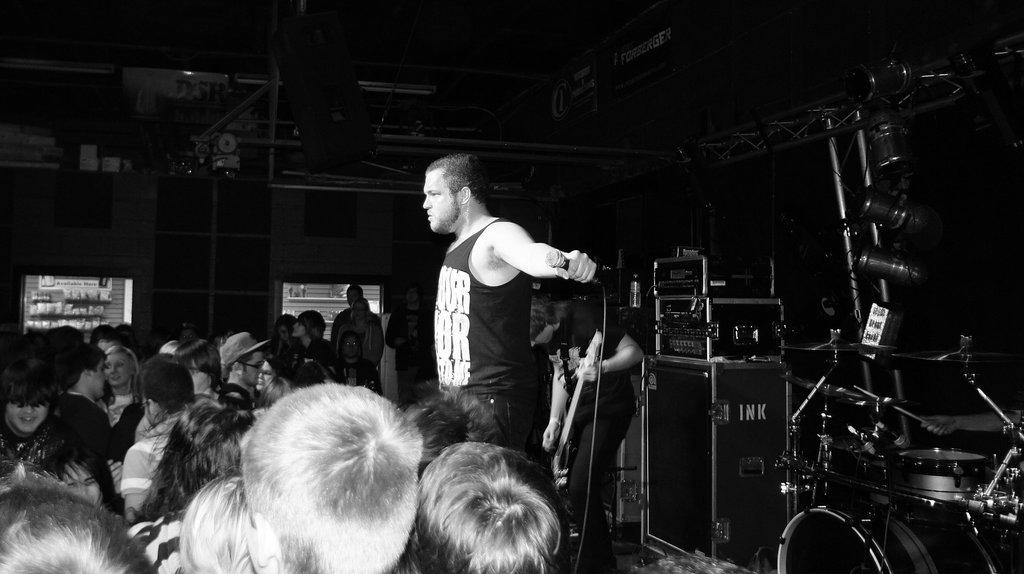Who is the main subject in the image? There is a man in the middle of the image. What is the man holding in the image? The man is holding a microphone. What objects are on the right side of the image? There are amplifiers, drums, and a speaker on the right side of the image. What can be seen on the left side of the image? There are people on the left side of the image. What type of trousers is the man wearing in the image? The provided facts do not mention the man's trousers, so we cannot determine the type of trousers he is wearing. How many cans of soda are visible in the image? There is no mention of cans of soda in the provided facts, so we cannot determine if any are visible in the image. 